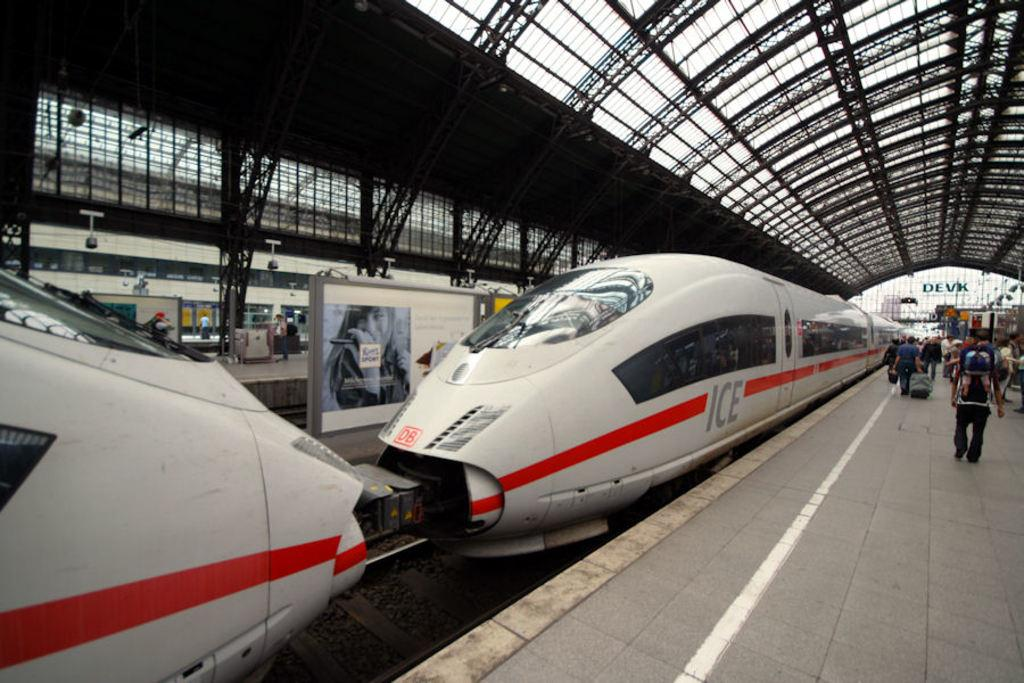<image>
Share a concise interpretation of the image provided. sleek white and red striped ICE trains at a station 